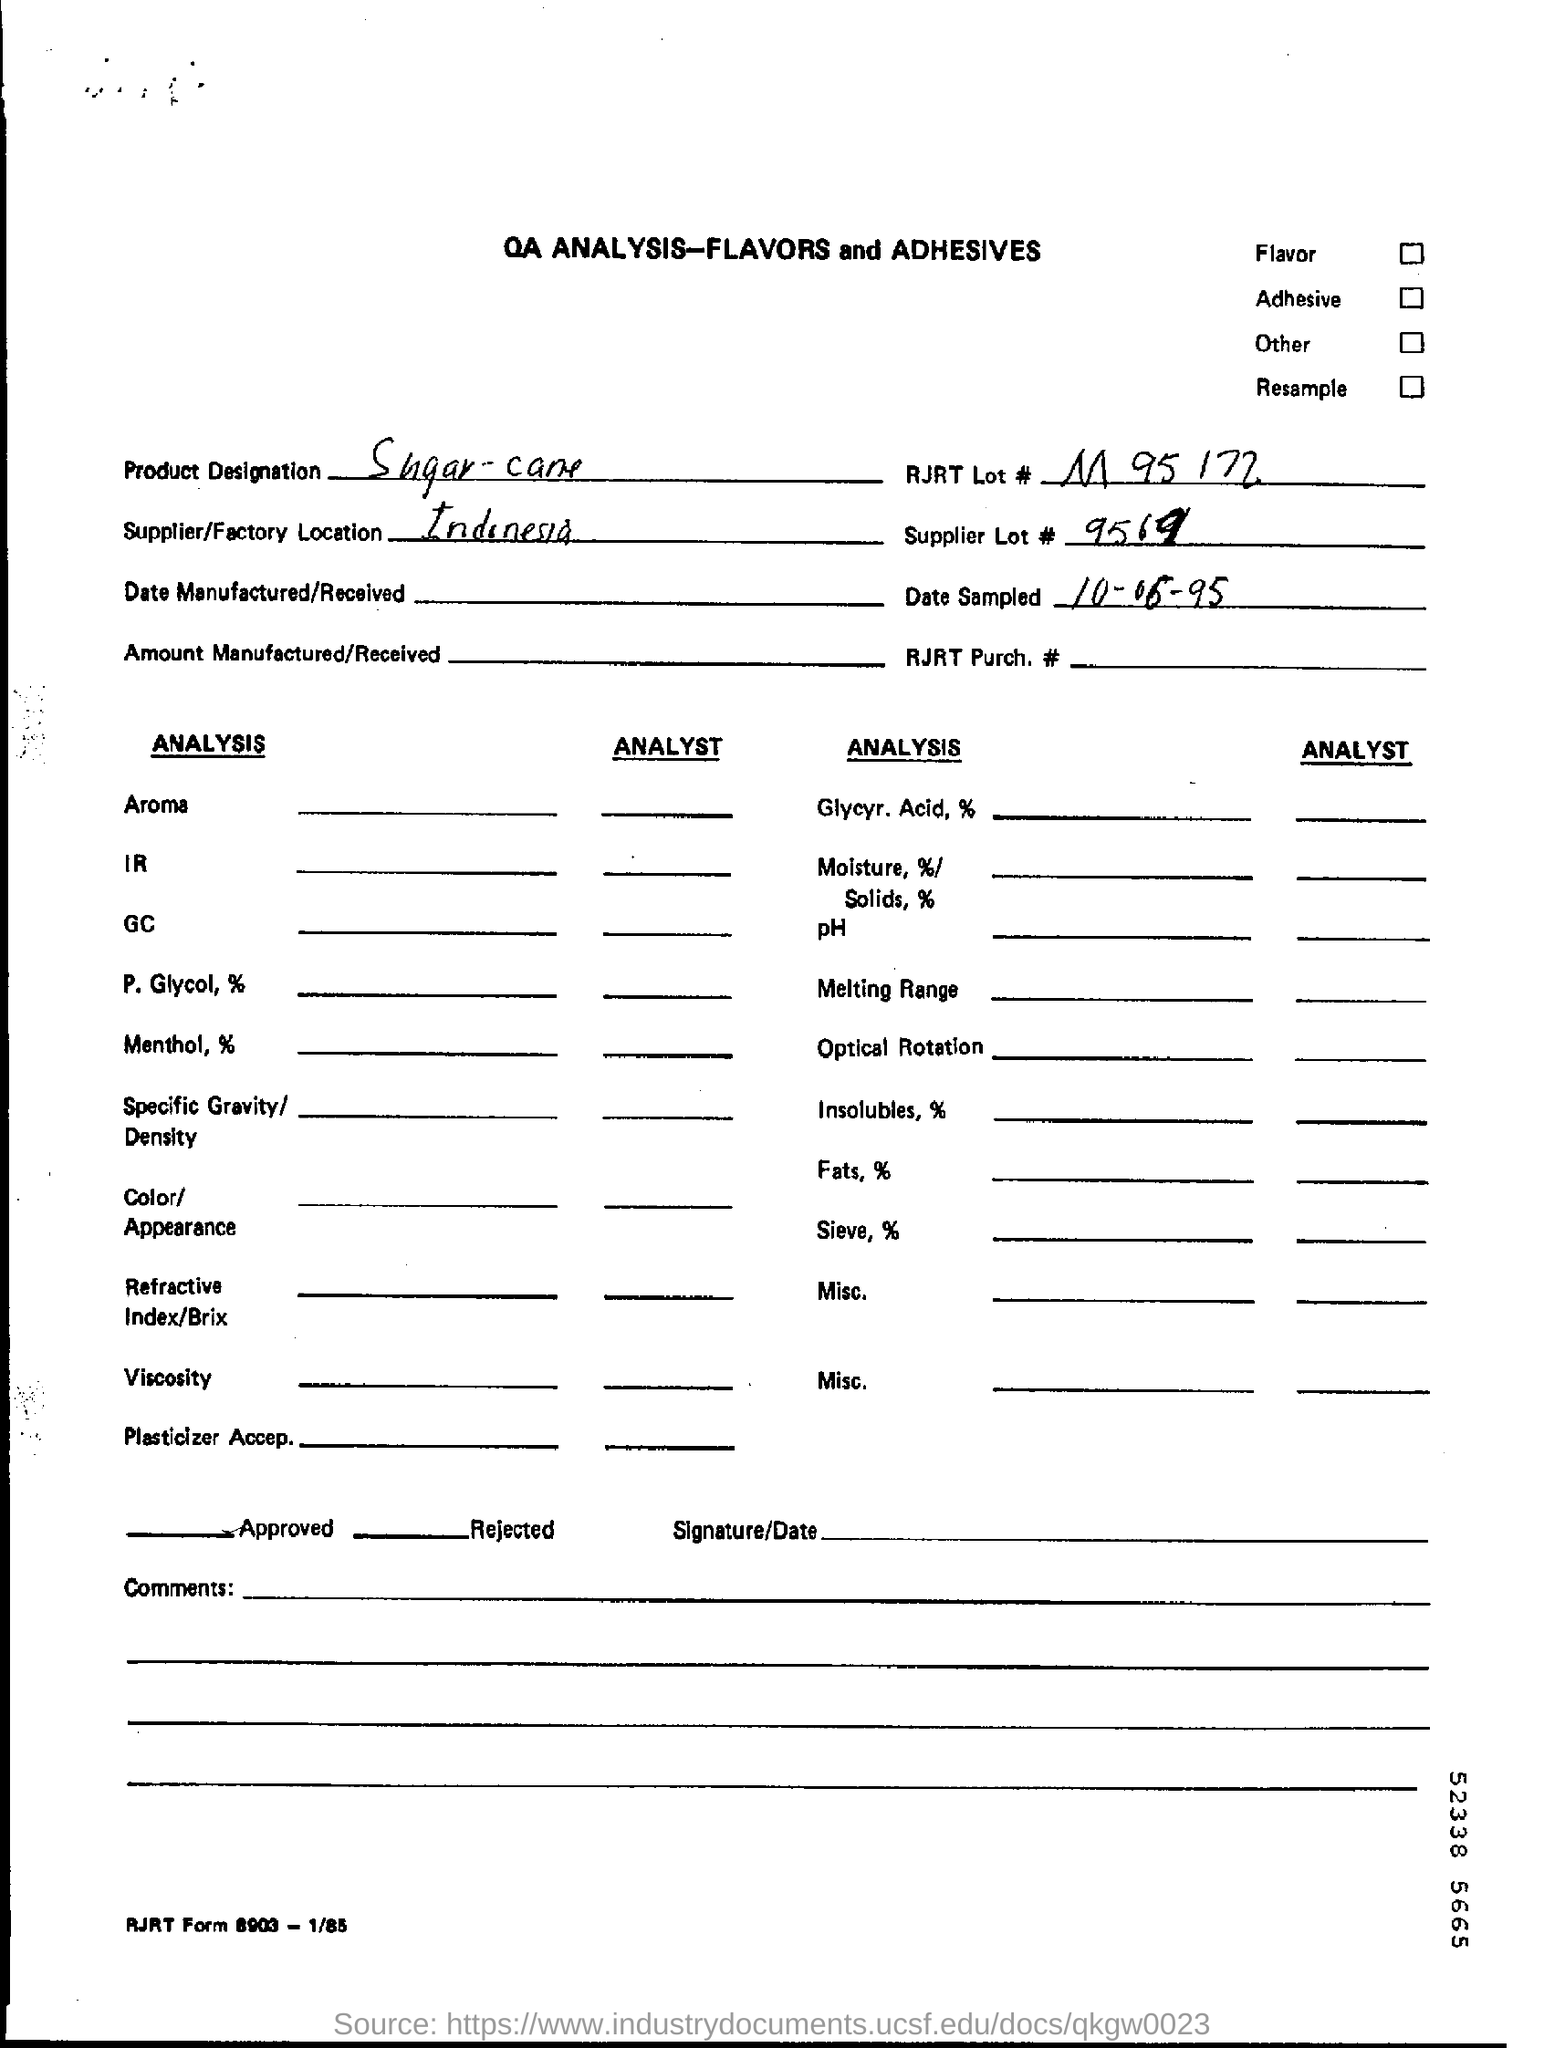What is the product designation?
Your answer should be very brief. Sugar-cane. What is RJRT Lot number?
Keep it short and to the point. M 95 172. Where is the supplier/ factory location?
Your answer should be very brief. Indonesia. What is the supplier lot number?
Keep it short and to the point. 9569. When was the date sampled?
Offer a very short reply. 10-06-95. 